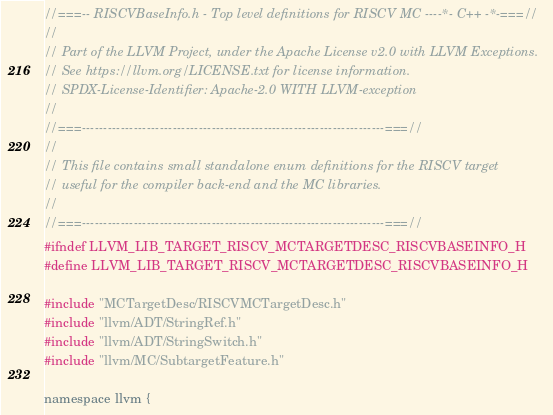<code> <loc_0><loc_0><loc_500><loc_500><_C_>//===-- RISCVBaseInfo.h - Top level definitions for RISCV MC ----*- C++ -*-===//
//
// Part of the LLVM Project, under the Apache License v2.0 with LLVM Exceptions.
// See https://llvm.org/LICENSE.txt for license information.
// SPDX-License-Identifier: Apache-2.0 WITH LLVM-exception
//
//===----------------------------------------------------------------------===//
//
// This file contains small standalone enum definitions for the RISCV target
// useful for the compiler back-end and the MC libraries.
//
//===----------------------------------------------------------------------===//
#ifndef LLVM_LIB_TARGET_RISCV_MCTARGETDESC_RISCVBASEINFO_H
#define LLVM_LIB_TARGET_RISCV_MCTARGETDESC_RISCVBASEINFO_H

#include "MCTargetDesc/RISCVMCTargetDesc.h"
#include "llvm/ADT/StringRef.h"
#include "llvm/ADT/StringSwitch.h"
#include "llvm/MC/SubtargetFeature.h"

namespace llvm {
</code> 